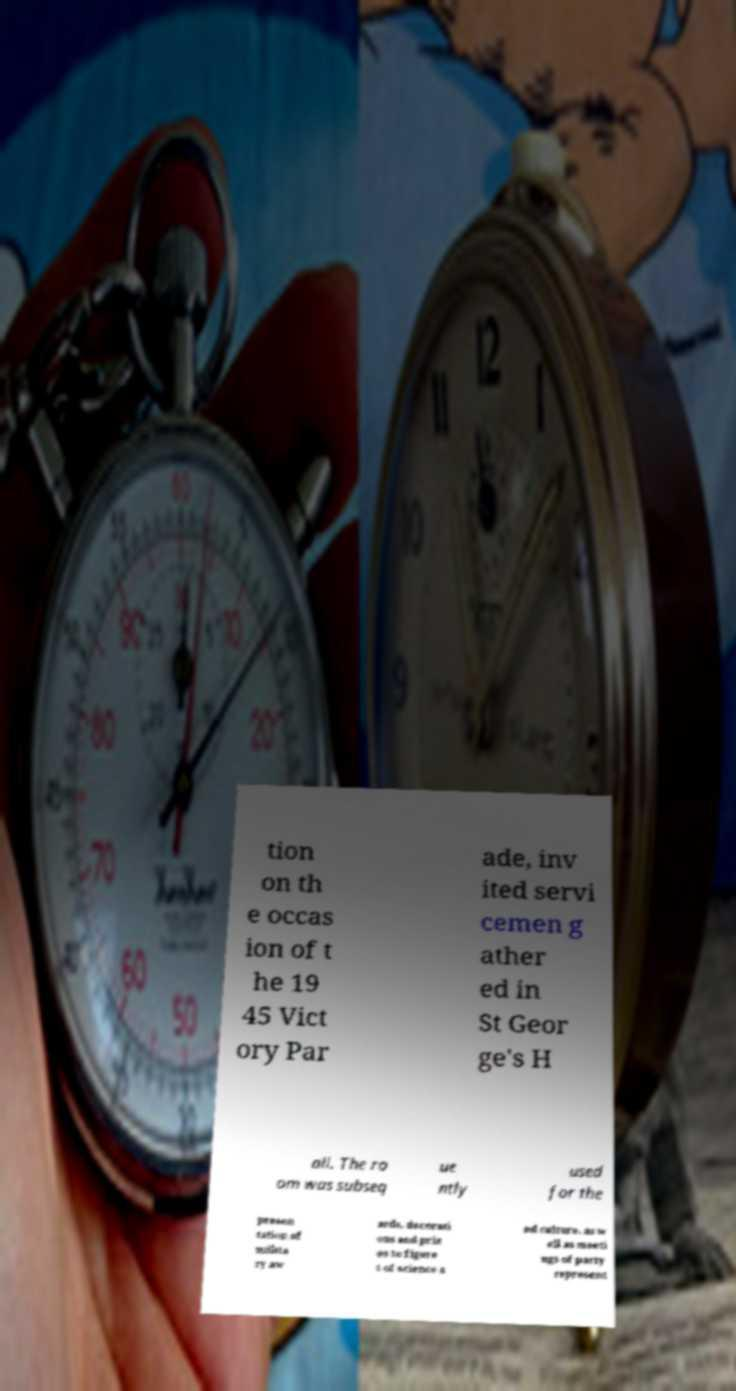There's text embedded in this image that I need extracted. Can you transcribe it verbatim? tion on th e occas ion of t he 19 45 Vict ory Par ade, inv ited servi cemen g ather ed in St Geor ge's H all. The ro om was subseq ue ntly used for the presen tation of milita ry aw ards, decorati ons and priz es to figure s of science a nd culture, as w ell as meeti ngs of party represent 